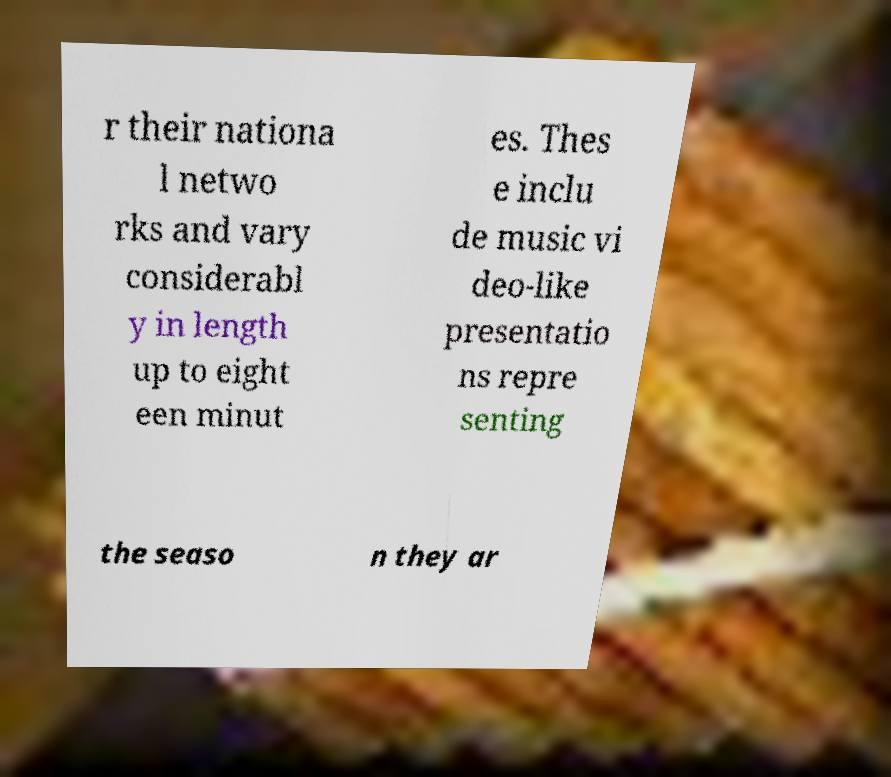Can you read and provide the text displayed in the image?This photo seems to have some interesting text. Can you extract and type it out for me? r their nationa l netwo rks and vary considerabl y in length up to eight een minut es. Thes e inclu de music vi deo-like presentatio ns repre senting the seaso n they ar 